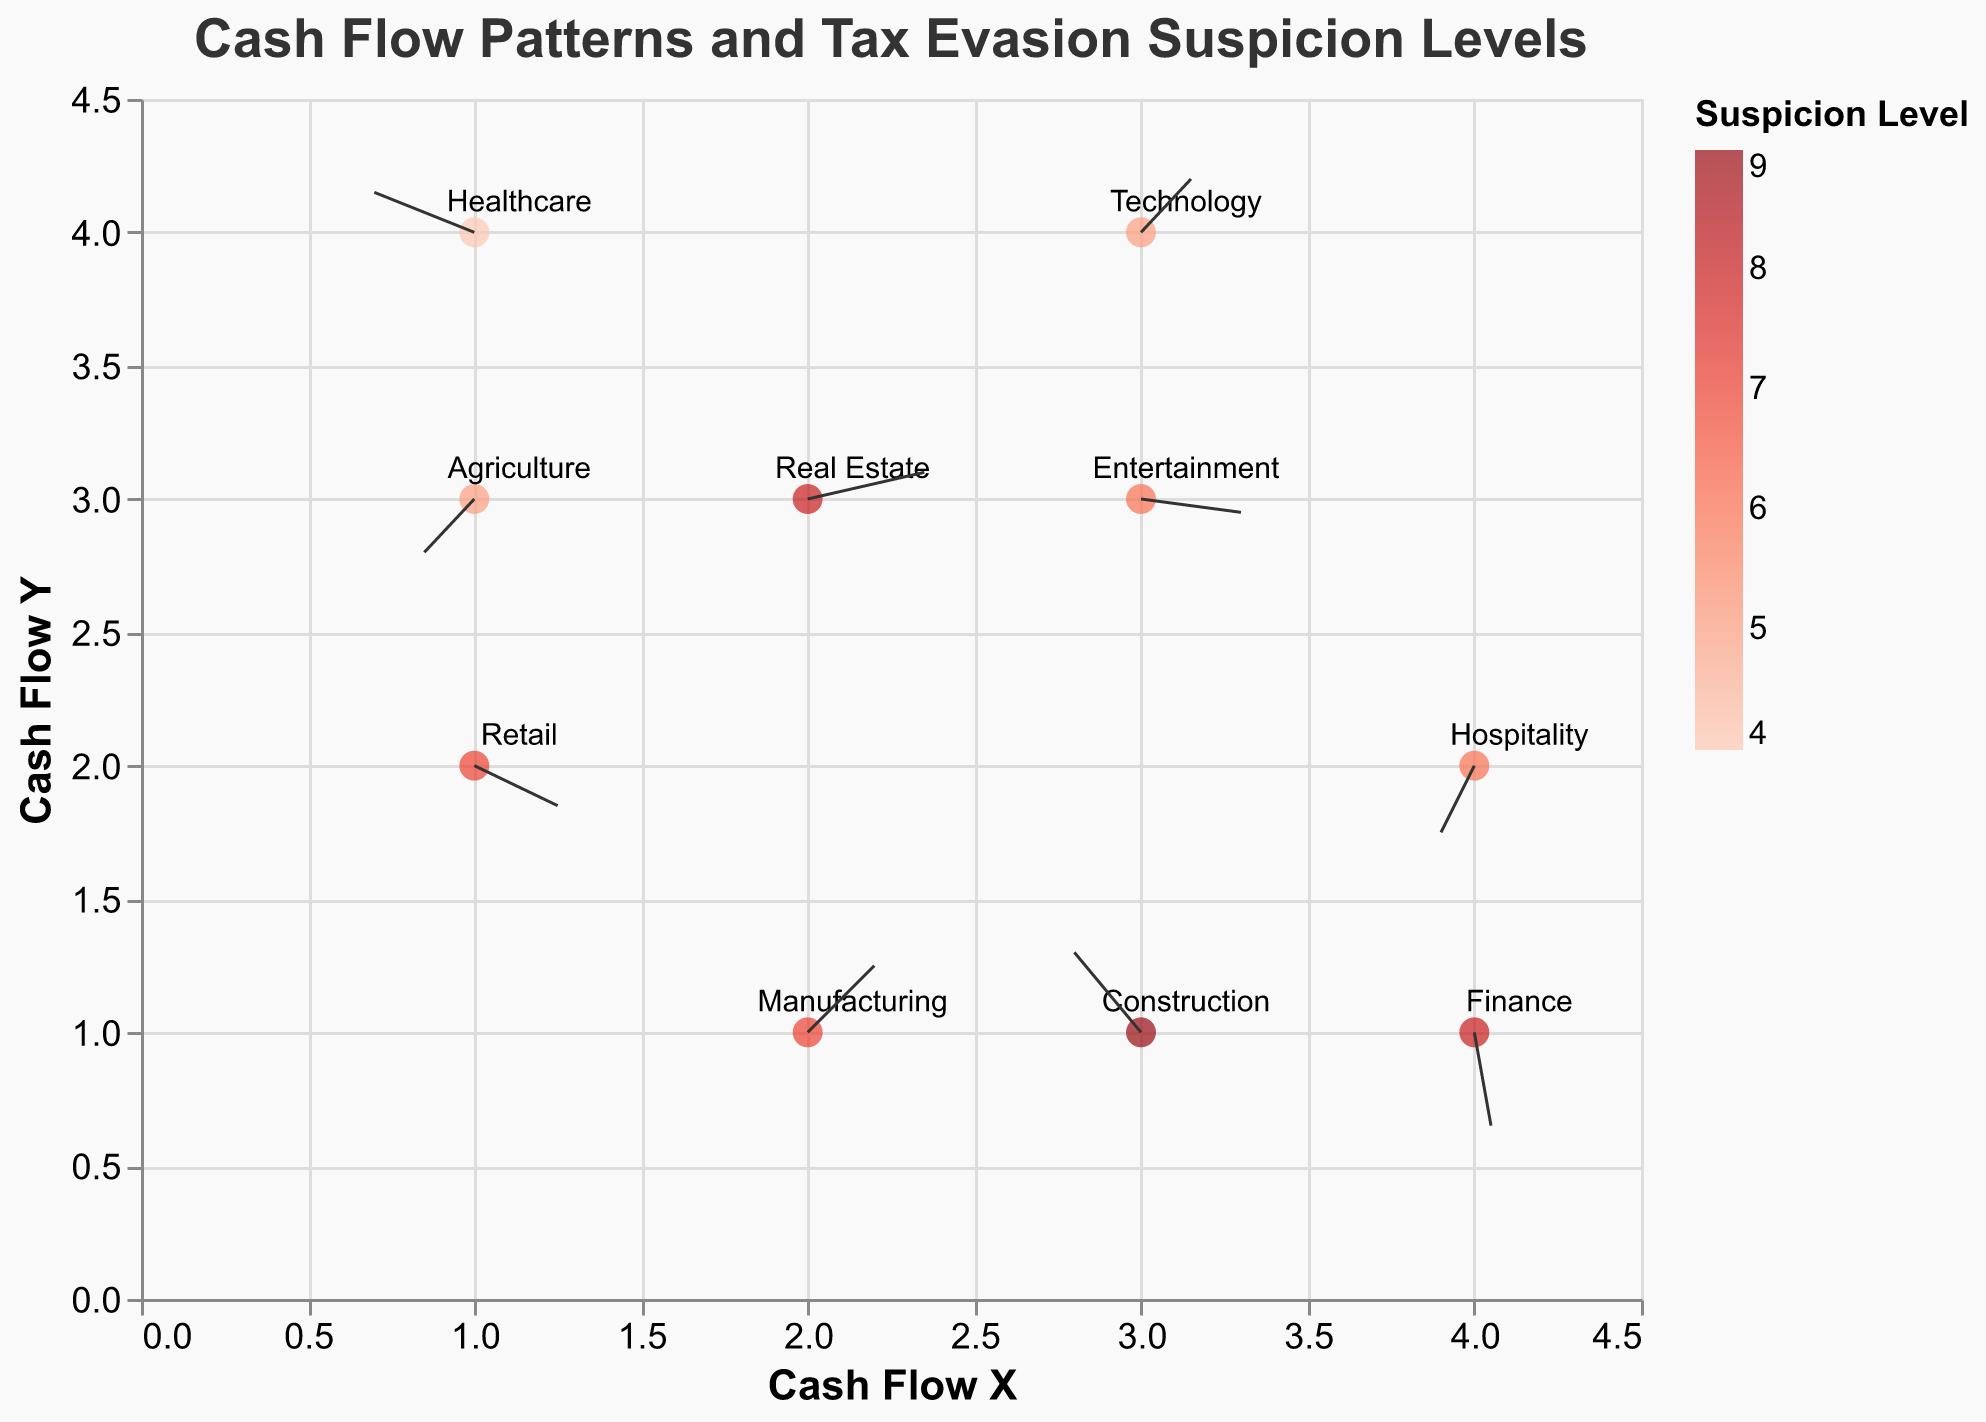What is the title of the figure? The title of the figure can be found at the top of the plot, where it is usually positioned to summarize the visualized data.
Answer: Cash Flow Patterns and Tax Evasion Suspicion Levels How many business sectors are shown in the plot? By counting the different labeled points and sectors in the tooltip information, you can determine the number of business sectors represented.
Answer: 10 Which sector has the highest suspicion level of tax evasion? By examining the color gradient from the legend and checking the tooltip data, the sector with the highest suspicion level is identified.
Answer: Construction (Suspicion Level 9) What is the movement vector (U, V) and suspicion level for the Technology sector? Locate the specific label for the Technology sector on the plot and refer to the direction and length of the arrow, along with color intensity for suspicion level shown in the tooltip.
Answer: (0.3, 0.4), Suspicion Level 5 Which sector shows a positive cash flow change in both directions (both U and V are positive)? By analyzing the directions and labels of vectors for each sector, you can find sectors where both U and V components are positive.
Answer: Technology What is the change in cash flow vector (U, V) for the Retail sector? Look at the arrow originating from the point labeled 'Retail' and check its direction and length along the U and V axes.
Answer: (0.5, -0.3) Compare the suspicion levels of the Finance and Manufacturing sectors. Which sector has a higher suspicion level? Locate both sectors on the plot and compare the color gradients or the values shown in the tooltip to determine which one has a higher suspicion level.
Answer: Finance (Suspicion Level 8) is higher than Manufacturing (Suspicion Level 7) Which sector demonstrates a negative cash flow change in both directions (both U and V are negative)? Analyze the vectors for each sector and identify sectors where both U and V components are negative.
Answer: Hospitality Calculate the average suspicion level across all sectors. Add all the suspicion levels together: (7 + 9 + 8 + 6 + 5 + 4 + 8 + 7 + 5 + 6) = 65, then divide by the number of sectors: 65 / 10 = 6.5
Answer: 6.5 Which sector has the smallest change in cash flow along the X-axis (U component is closest to zero)? Look for the smallest U component value among all sectors by checking each tooltip or vector direction
Answer: Finance (0.1) 